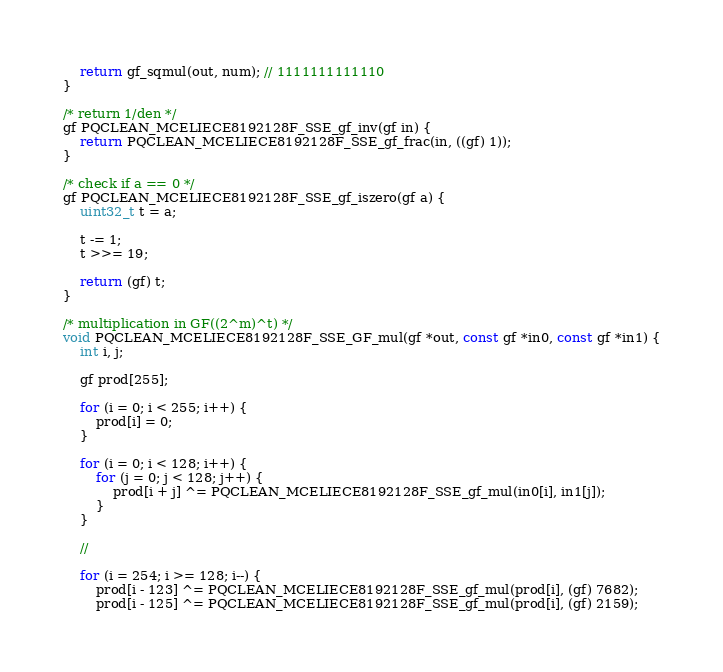Convert code to text. <code><loc_0><loc_0><loc_500><loc_500><_C_>    return gf_sqmul(out, num); // 1111111111110
}

/* return 1/den */
gf PQCLEAN_MCELIECE8192128F_SSE_gf_inv(gf in) {
    return PQCLEAN_MCELIECE8192128F_SSE_gf_frac(in, ((gf) 1));
}

/* check if a == 0 */
gf PQCLEAN_MCELIECE8192128F_SSE_gf_iszero(gf a) {
    uint32_t t = a;

    t -= 1;
    t >>= 19;

    return (gf) t;
}

/* multiplication in GF((2^m)^t) */
void PQCLEAN_MCELIECE8192128F_SSE_GF_mul(gf *out, const gf *in0, const gf *in1) {
    int i, j;

    gf prod[255];

    for (i = 0; i < 255; i++) {
        prod[i] = 0;
    }

    for (i = 0; i < 128; i++) {
        for (j = 0; j < 128; j++) {
            prod[i + j] ^= PQCLEAN_MCELIECE8192128F_SSE_gf_mul(in0[i], in1[j]);
        }
    }

    //

    for (i = 254; i >= 128; i--) {
        prod[i - 123] ^= PQCLEAN_MCELIECE8192128F_SSE_gf_mul(prod[i], (gf) 7682);
        prod[i - 125] ^= PQCLEAN_MCELIECE8192128F_SSE_gf_mul(prod[i], (gf) 2159);</code> 